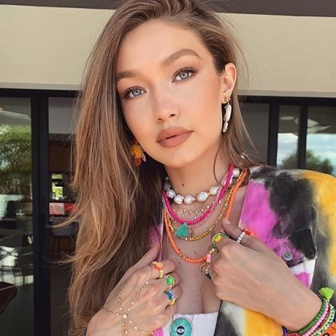Imagine a whimsical story where the woman in the image discovers a secret hidden within the urban environment. What does she find? In a twist of fate, the young woman discovers an ancient, mystical amulet hidden within a crack in the wall of the building behind her. This amulet, unbeknownst to its finder, possesses the power to unlock hidden dimensions within the urban environment. As she places the amulet around her neck, the city transforms around her; walls become transparent, revealing hidden passageways and celestial gardens that only a select few can navigate. An adventure ensues where she unravels secrets of an ancient civilization intertwined with the modern city, leading her to collaborate with other secret keepers to protect the mystical heritage within... 